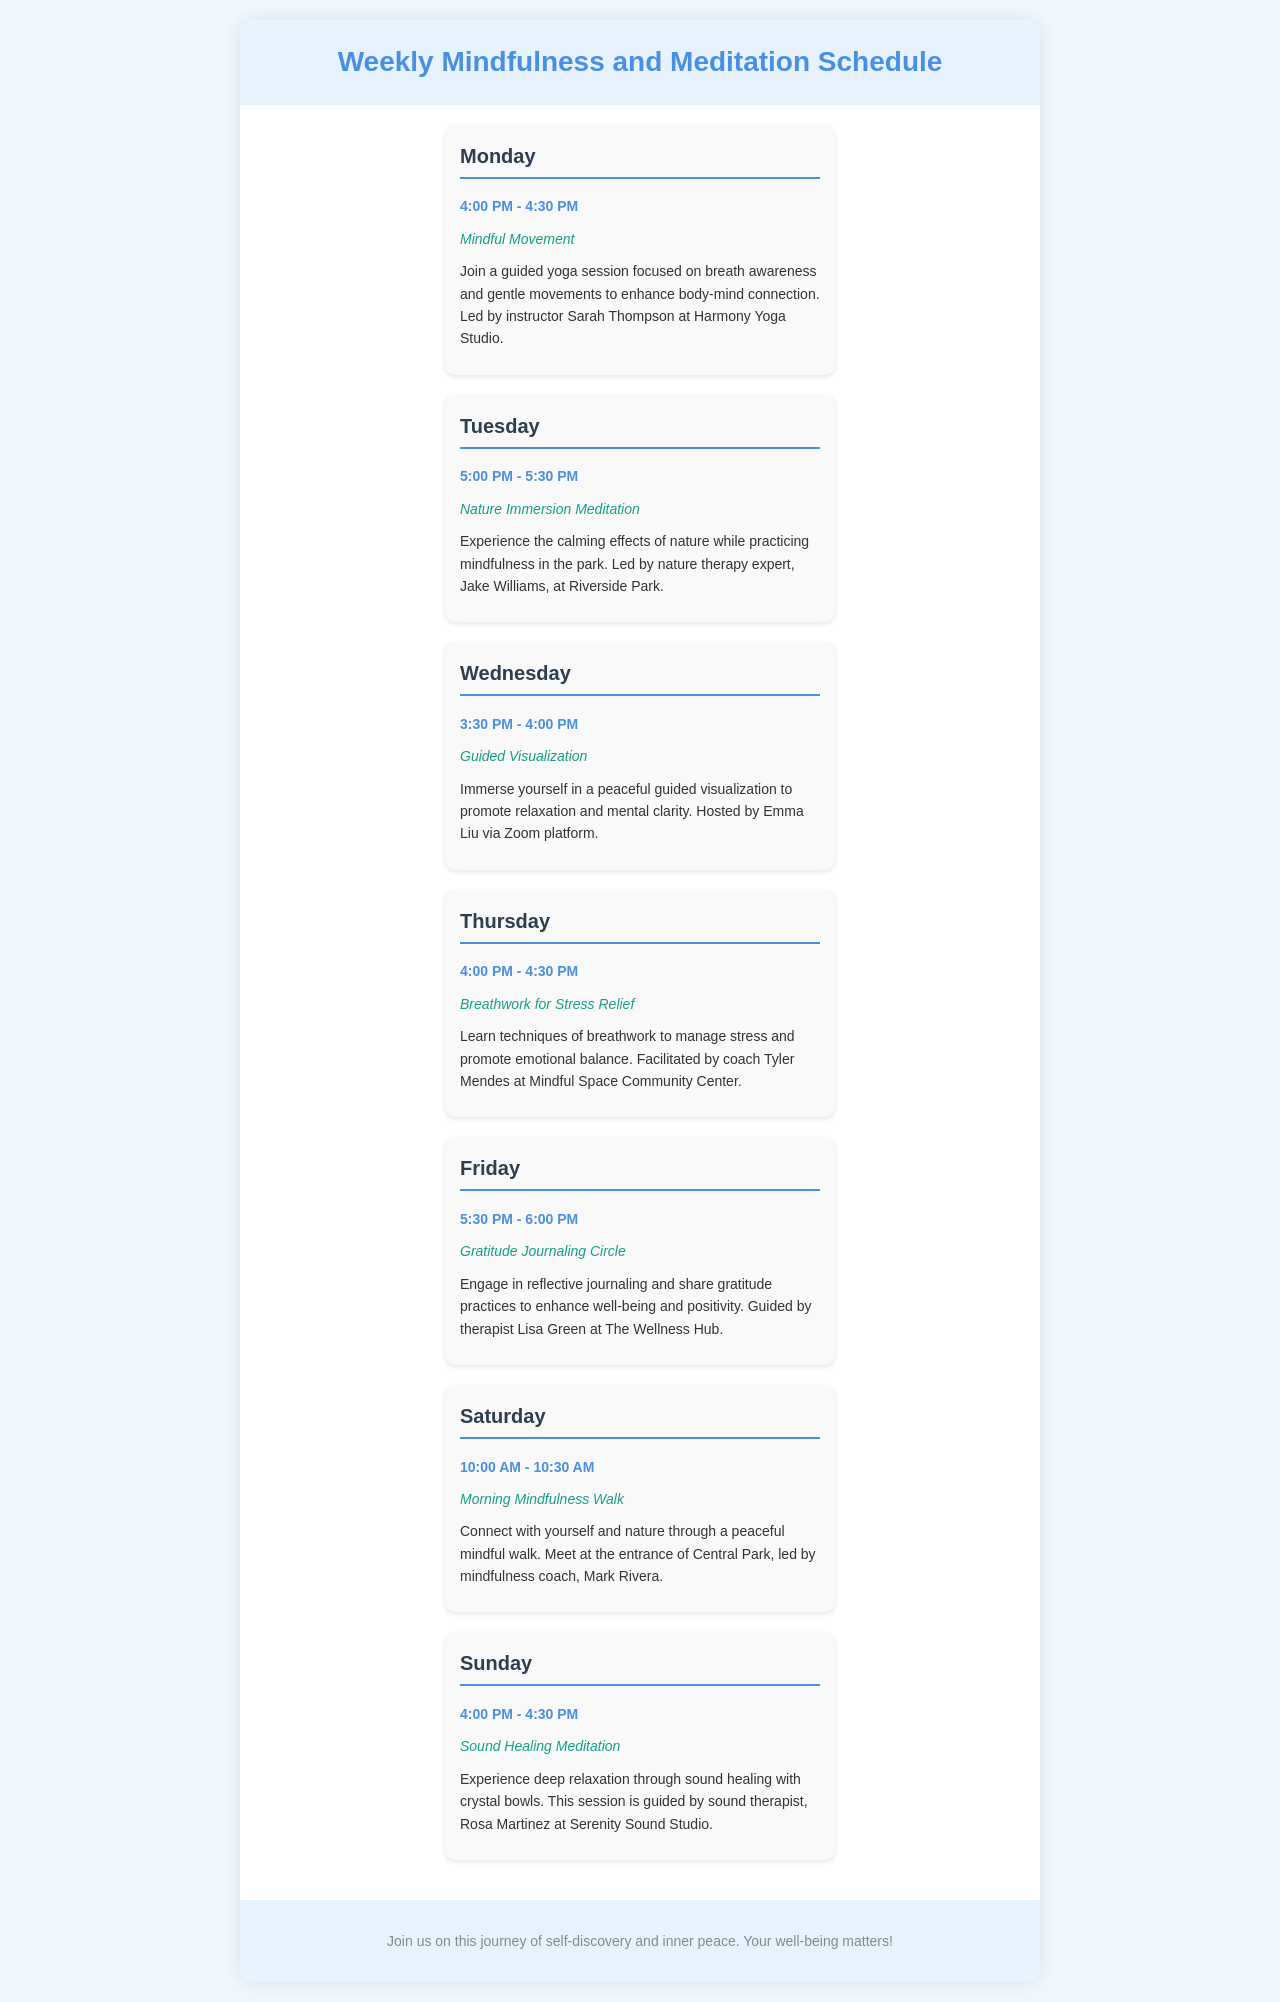What time does the Mindful Movement session start? The Mindful Movement session starts at 4:00 PM on Monday.
Answer: 4:00 PM Who is the instructor for the Nature Immersion Meditation? The instructor for the Nature Immersion Meditation is Jake Williams.
Answer: Jake Williams On which day is the Gratitude Journaling Circle held? The Gratitude Journaling Circle is held on Friday.
Answer: Friday What session is offered at 10:00 AM on Saturday? The session offered at 10:00 AM on Saturday is the Morning Mindfulness Walk.
Answer: Morning Mindfulness Walk How long is each mindfulness session? Each mindfulness session is typically 30 minutes long.
Answer: 30 minutes Which instructor leads the Sound Healing Meditation? The Sound Healing Meditation is led by Rosa Martinez.
Answer: Rosa Martinez What is the location for the Breathwork for Stress Relief session? The location for the Breathwork for Stress Relief session is Mindful Space Community Center.
Answer: Mindful Space Community Center How many days are mindfulness sessions scheduled for? There are mindfulness sessions scheduled for seven days.
Answer: Seven days What type of session is held on Wednesday? The type of session held on Wednesday is Guided Visualization.
Answer: Guided Visualization 